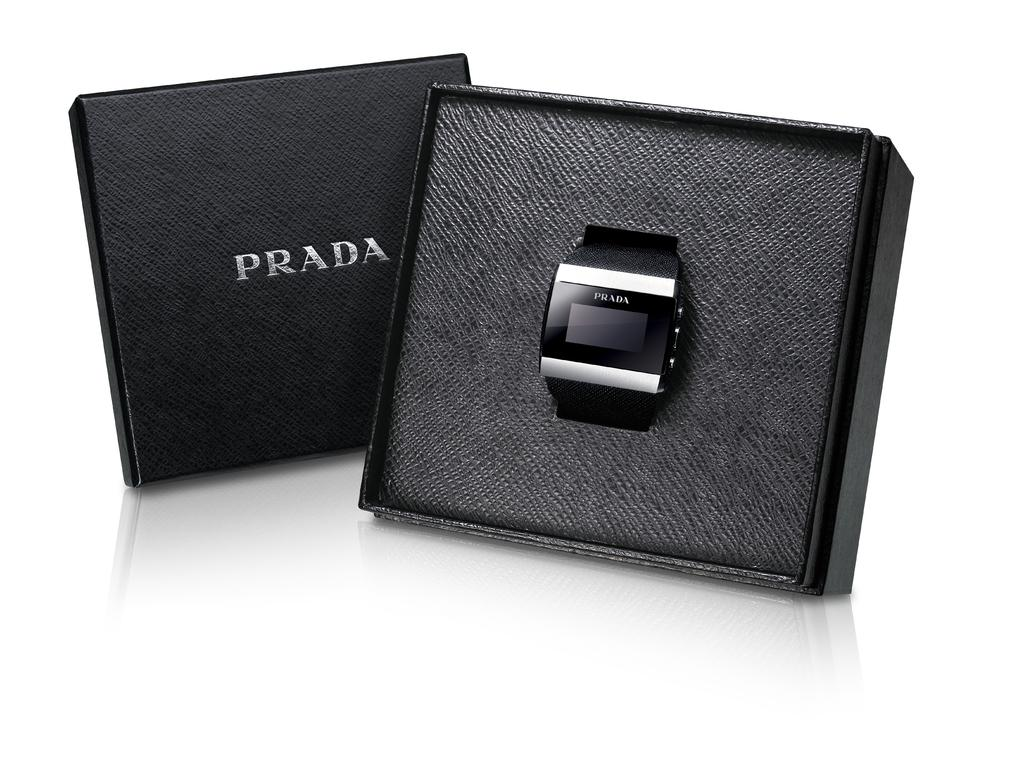<image>
Present a compact description of the photo's key features. A Prada watch with a black face and band with silver trim on the bezel. 